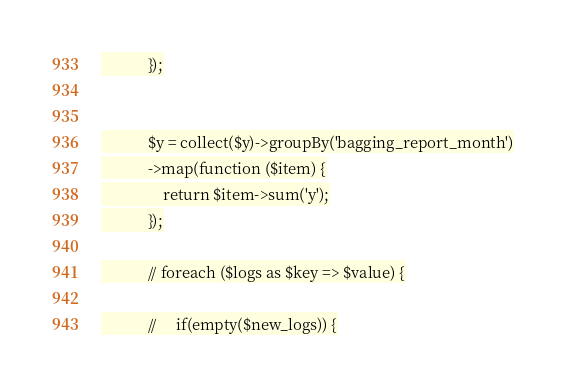Convert code to text. <code><loc_0><loc_0><loc_500><loc_500><_PHP_>            });


            $y = collect($y)->groupBy('bagging_report_month')
            ->map(function ($item) {
                return $item->sum('y');
            });

            // foreach ($logs as $key => $value) {

            //     if(empty($new_logs)) {
</code> 